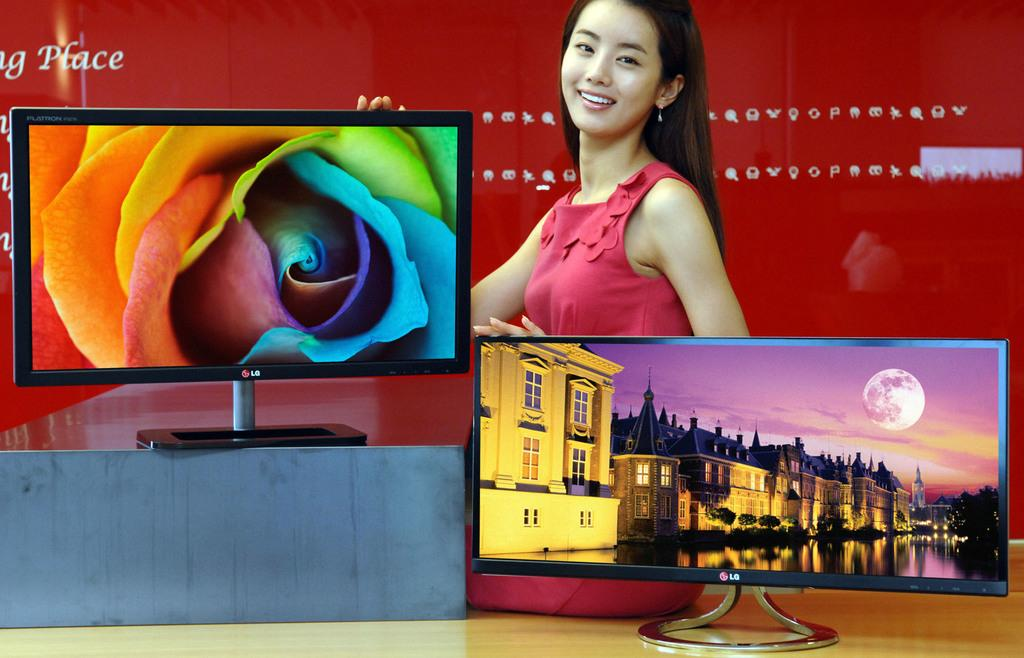<image>
Render a clear and concise summary of the photo. a pair of LG televisions being shown off by a woman in a red dress. 